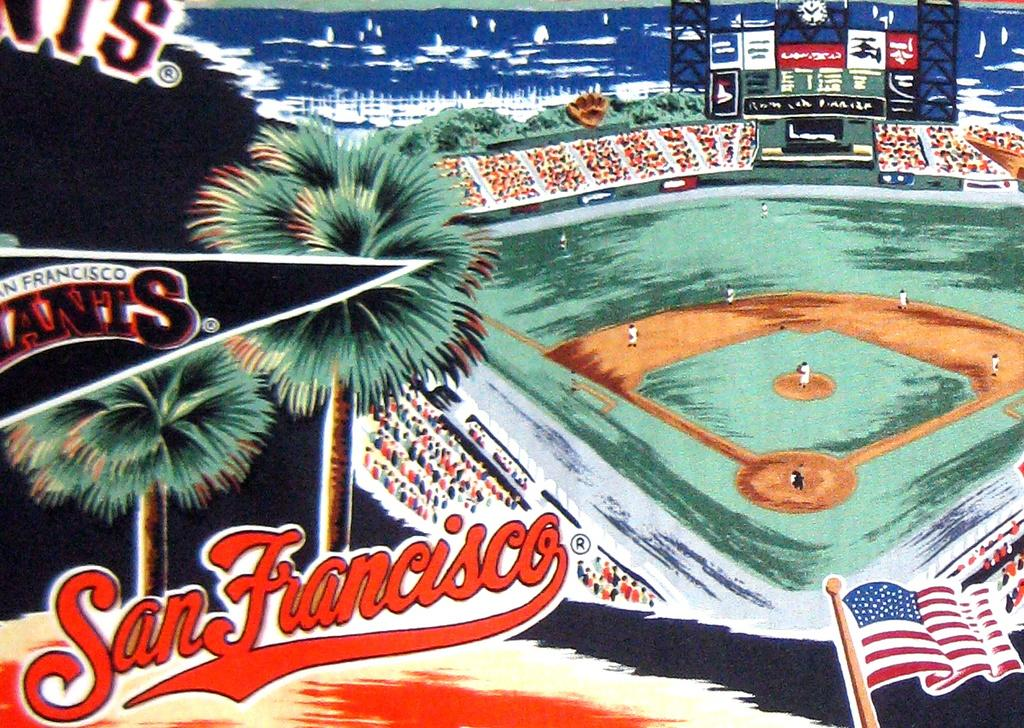<image>
Relay a brief, clear account of the picture shown. an illustration of the san francisco base ball stadium. 